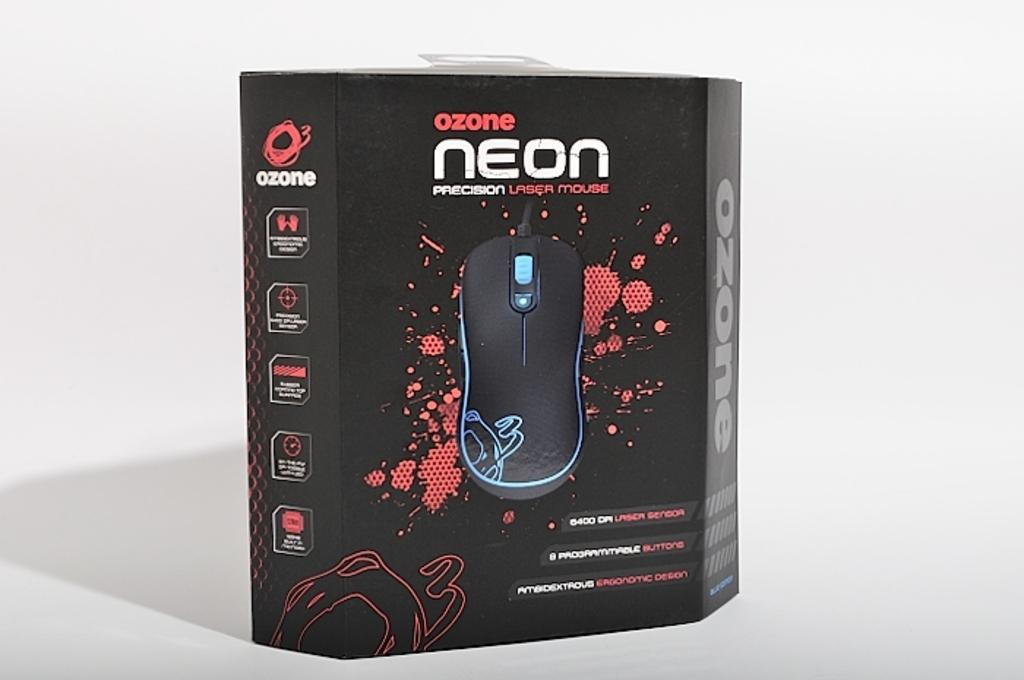What type of container is in the image? There is a mouse box in the image. What color is the mouse box? The mouse box is black in color. On what surface is the mouse box placed? The mouse box is on a white surface. What is inside the mouse box? There is a mouse inside the box. What name is written on the mouse box? The name "Ozone Neon" is written on the box. What type of grass is growing inside the mouse box? There is no grass present inside the mouse box; it contains a mouse. 